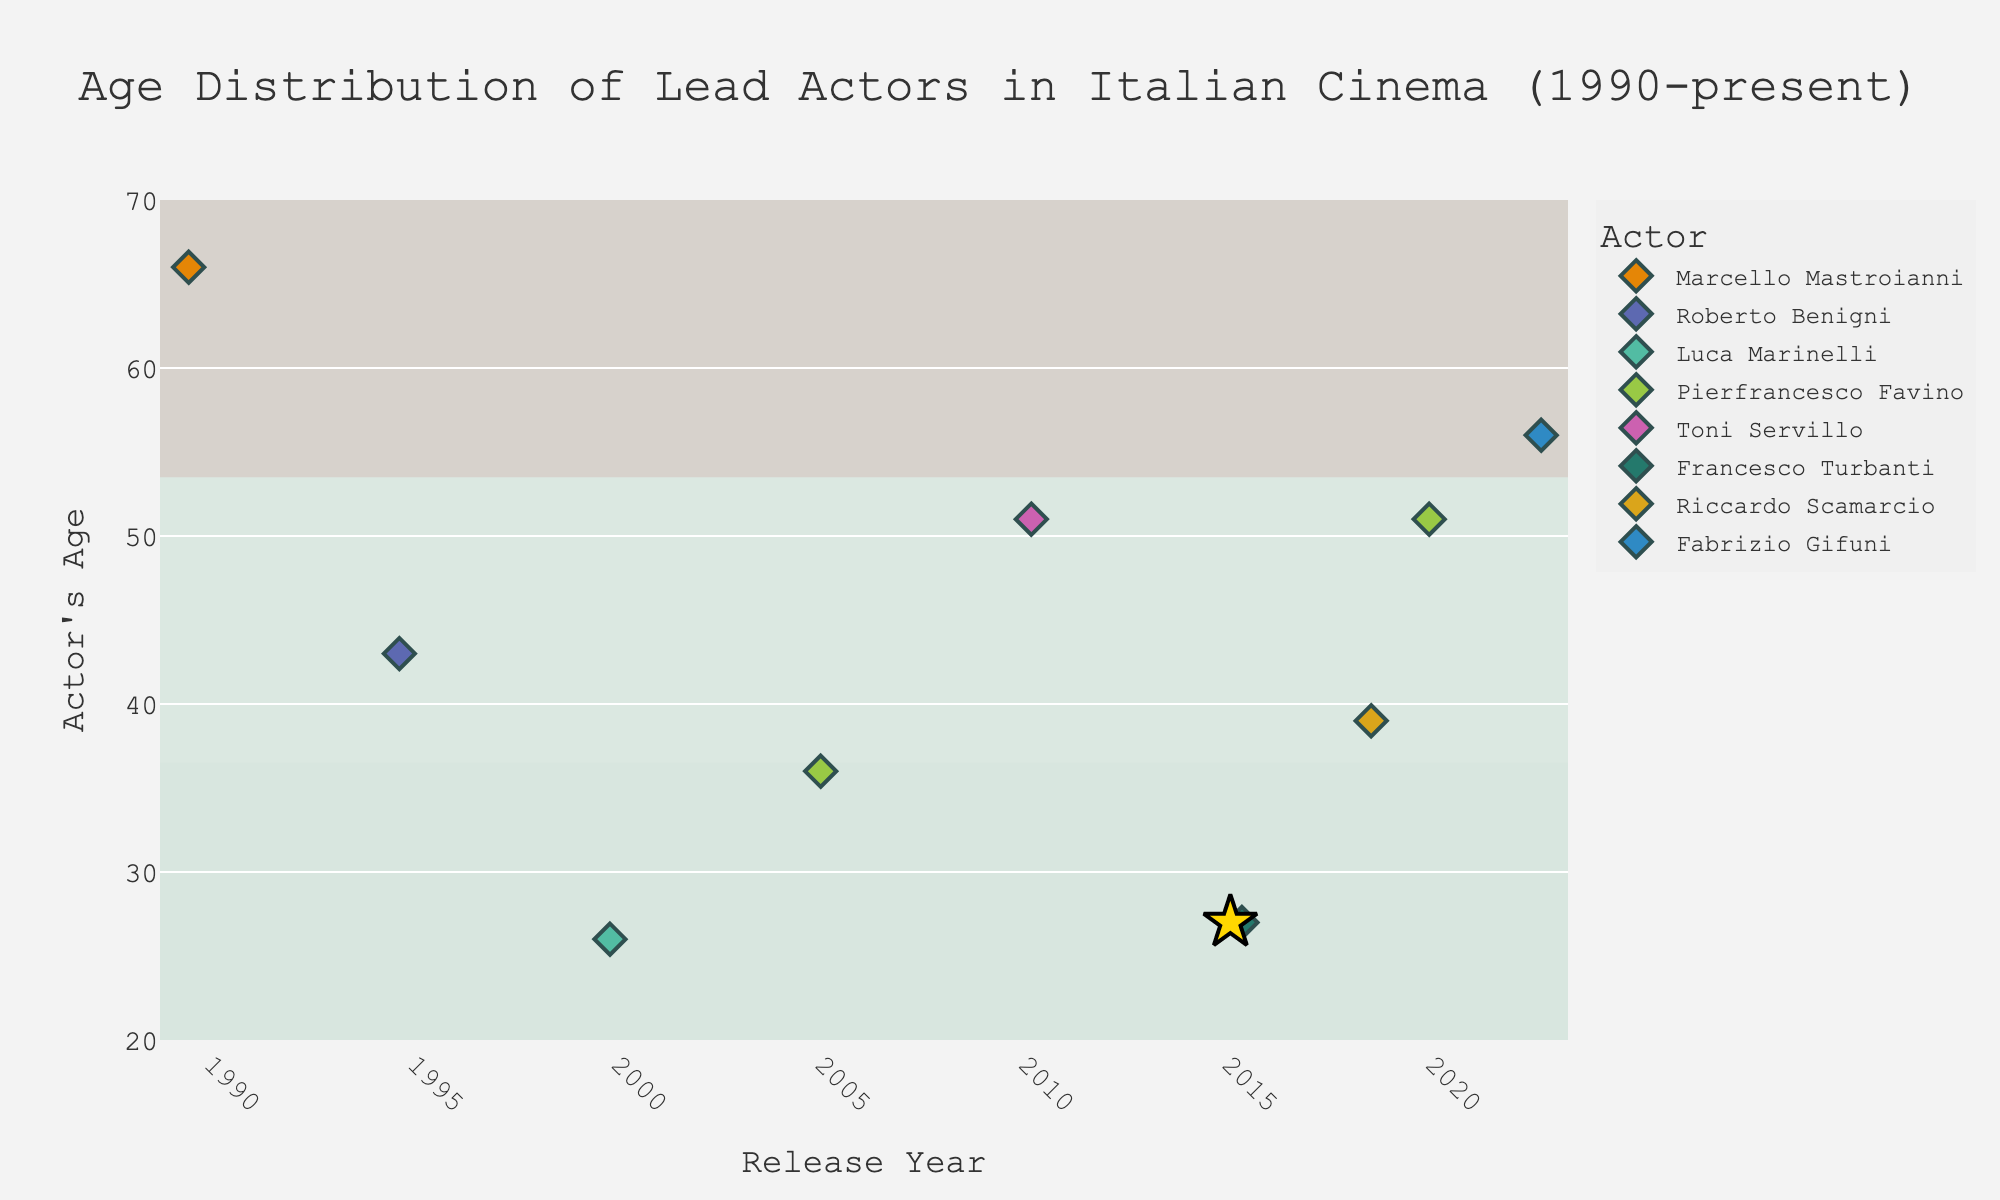What is the title of the figure? The figure's title is usually written at the top of the plot. It summarizes what the plot represents. Here, it tells us that the plot shows the age distribution of lead actors in Italian cinema from 1990 to the present.
Answer: "Age Distribution of Lead Actors in Italian Cinema (1990-present)" Which actor was the oldest in the dataset? To find the oldest actor, look for the data point with the highest age value on the y-axis. Marcello Mastroianni's data point is the highest at 66 years in 1990.
Answer: Marcello Mastroianni In which year did Francesco Turbanti appear, and how old was he? Look for Francesco Turbanti's highlighted data point (a golden star) on the plot. It shows that he appeared in the year 2015 and was 27 years old.
Answer: 2015, 27 Who were the lead actors in Italian cinema in the year 2020, and what were their ages? Look along the year 2020 and identify the data points. Pierfrancesco Favino is marked in 2020 with an age of 51 years.
Answer: Pierfrancesco Favino, 51 Compare the ages of the lead actors in the years 2000 and 2010. Who was the younger actor and by how many years? Identify the data points for 2000 and 2010. Luca Marinelli was 26 in 2000, and Toni Servillo was 51 in 2010. Subtracting these gives 51 - 26.
Answer: Luca Marinelli was younger by 25 years What is the average age of lead actors in the years 1990, 2000, and 2010? Identify the ages from the plot for these years: Marcello Mastroianni (1990) = 66, Luca Marinelli (2000) = 26, Toni Servillo (2010) = 51. The average is (66 + 26 + 51) / 3.
Answer: 47.67 Who was the lead actor in Romanzo Criminale and what was their age? Check the hover data or labels from the corresponding year 2005 on the plot. It shows Pierfrancesco Favino was the lead actor with an age of 36 years.
Answer: Pierfrancesco Favino, 36 Which two actors appear in the dataset more than once and what are their appearances? Look for actors with multiple data points. Pierfrancesco Favino appears twice in 2005 and 2020, while nobody else has more than one appearance.
Answer: Pierfrancesco Favino What is the range of ages displayed for the lead actors? The range is calculated by subtracting the smallest age value from the largest. The oldest actor was 66 (Marcello Mastroianni in 1990) and the youngest was 26 (Luca Marinelli in 2000). So, 66 - 26.
Answer: 40 How does Francesco Turbanti's age compare to the other actors in 2015? Francesco Turbanti's age is highlighted as 27 in 2015. Compare this with other data points in the same year if available. Since no data point overlaps in 2015, Turbanti's age stands out alone.
Answer: 27 years 